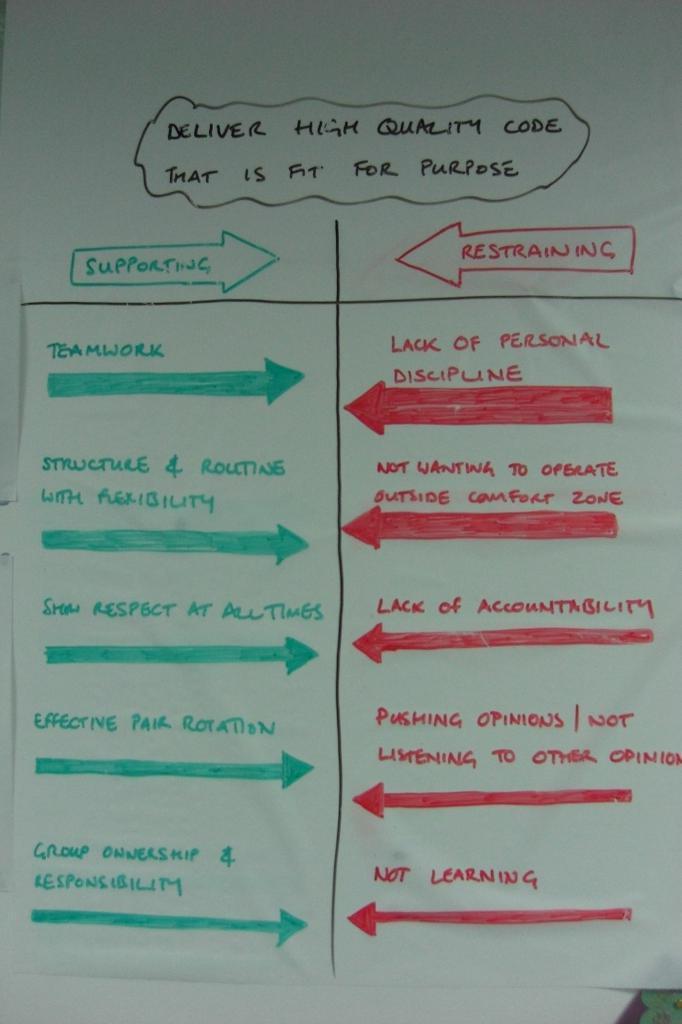Describe this image in one or two sentences. In the picture there is a paper, on the paper there is some text present. 